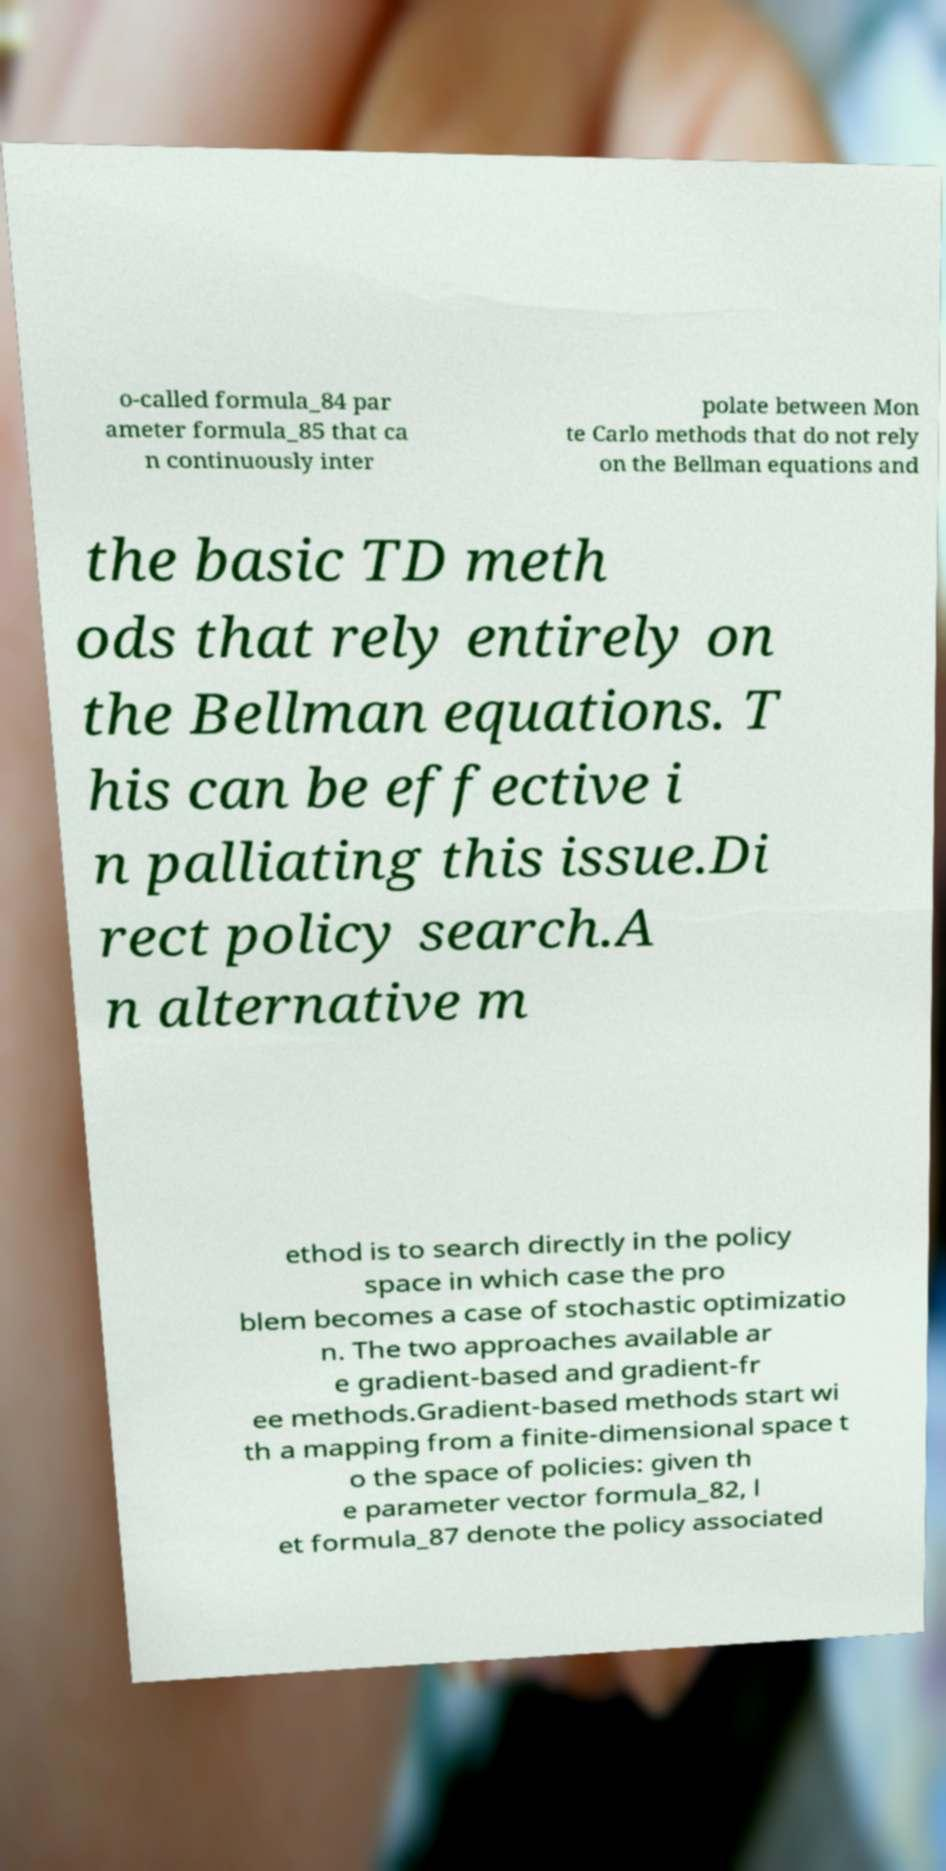I need the written content from this picture converted into text. Can you do that? o-called formula_84 par ameter formula_85 that ca n continuously inter polate between Mon te Carlo methods that do not rely on the Bellman equations and the basic TD meth ods that rely entirely on the Bellman equations. T his can be effective i n palliating this issue.Di rect policy search.A n alternative m ethod is to search directly in the policy space in which case the pro blem becomes a case of stochastic optimizatio n. The two approaches available ar e gradient-based and gradient-fr ee methods.Gradient-based methods start wi th a mapping from a finite-dimensional space t o the space of policies: given th e parameter vector formula_82, l et formula_87 denote the policy associated 